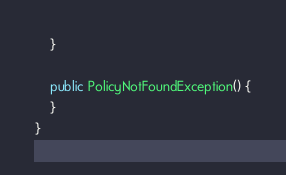Convert code to text. <code><loc_0><loc_0><loc_500><loc_500><_Java_>    }

    public PolicyNotFoundException() {
    }
}
</code> 